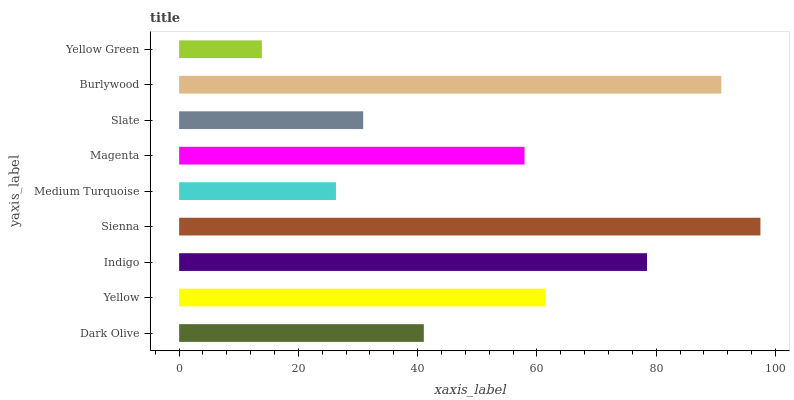Is Yellow Green the minimum?
Answer yes or no. Yes. Is Sienna the maximum?
Answer yes or no. Yes. Is Yellow the minimum?
Answer yes or no. No. Is Yellow the maximum?
Answer yes or no. No. Is Yellow greater than Dark Olive?
Answer yes or no. Yes. Is Dark Olive less than Yellow?
Answer yes or no. Yes. Is Dark Olive greater than Yellow?
Answer yes or no. No. Is Yellow less than Dark Olive?
Answer yes or no. No. Is Magenta the high median?
Answer yes or no. Yes. Is Magenta the low median?
Answer yes or no. Yes. Is Slate the high median?
Answer yes or no. No. Is Dark Olive the low median?
Answer yes or no. No. 